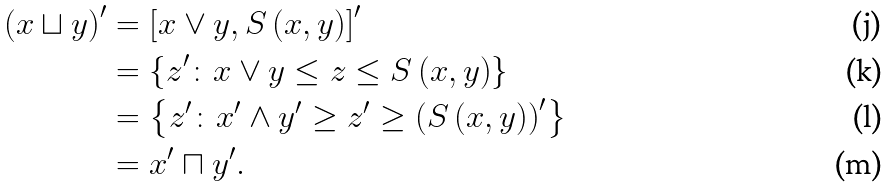<formula> <loc_0><loc_0><loc_500><loc_500>\left ( x \sqcup y \right ) ^ { \prime } & = \left [ x \vee y , S \left ( x , y \right ) \right ] ^ { \prime } \\ & = \left \{ z ^ { \prime } \colon x \vee y \leq z \leq S \left ( x , y \right ) \right \} \\ & = \left \{ z ^ { \prime } \colon x ^ { \prime } \wedge y ^ { \prime } \geq z ^ { \prime } \geq \left ( S \left ( x , y \right ) \right ) ^ { \prime } \right \} \\ & = x ^ { \prime } \sqcap y ^ { \prime } .</formula> 